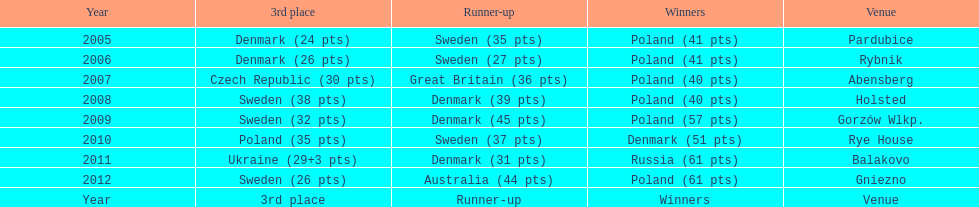What was the difference in final score between russia and denmark in 2011? 30. 